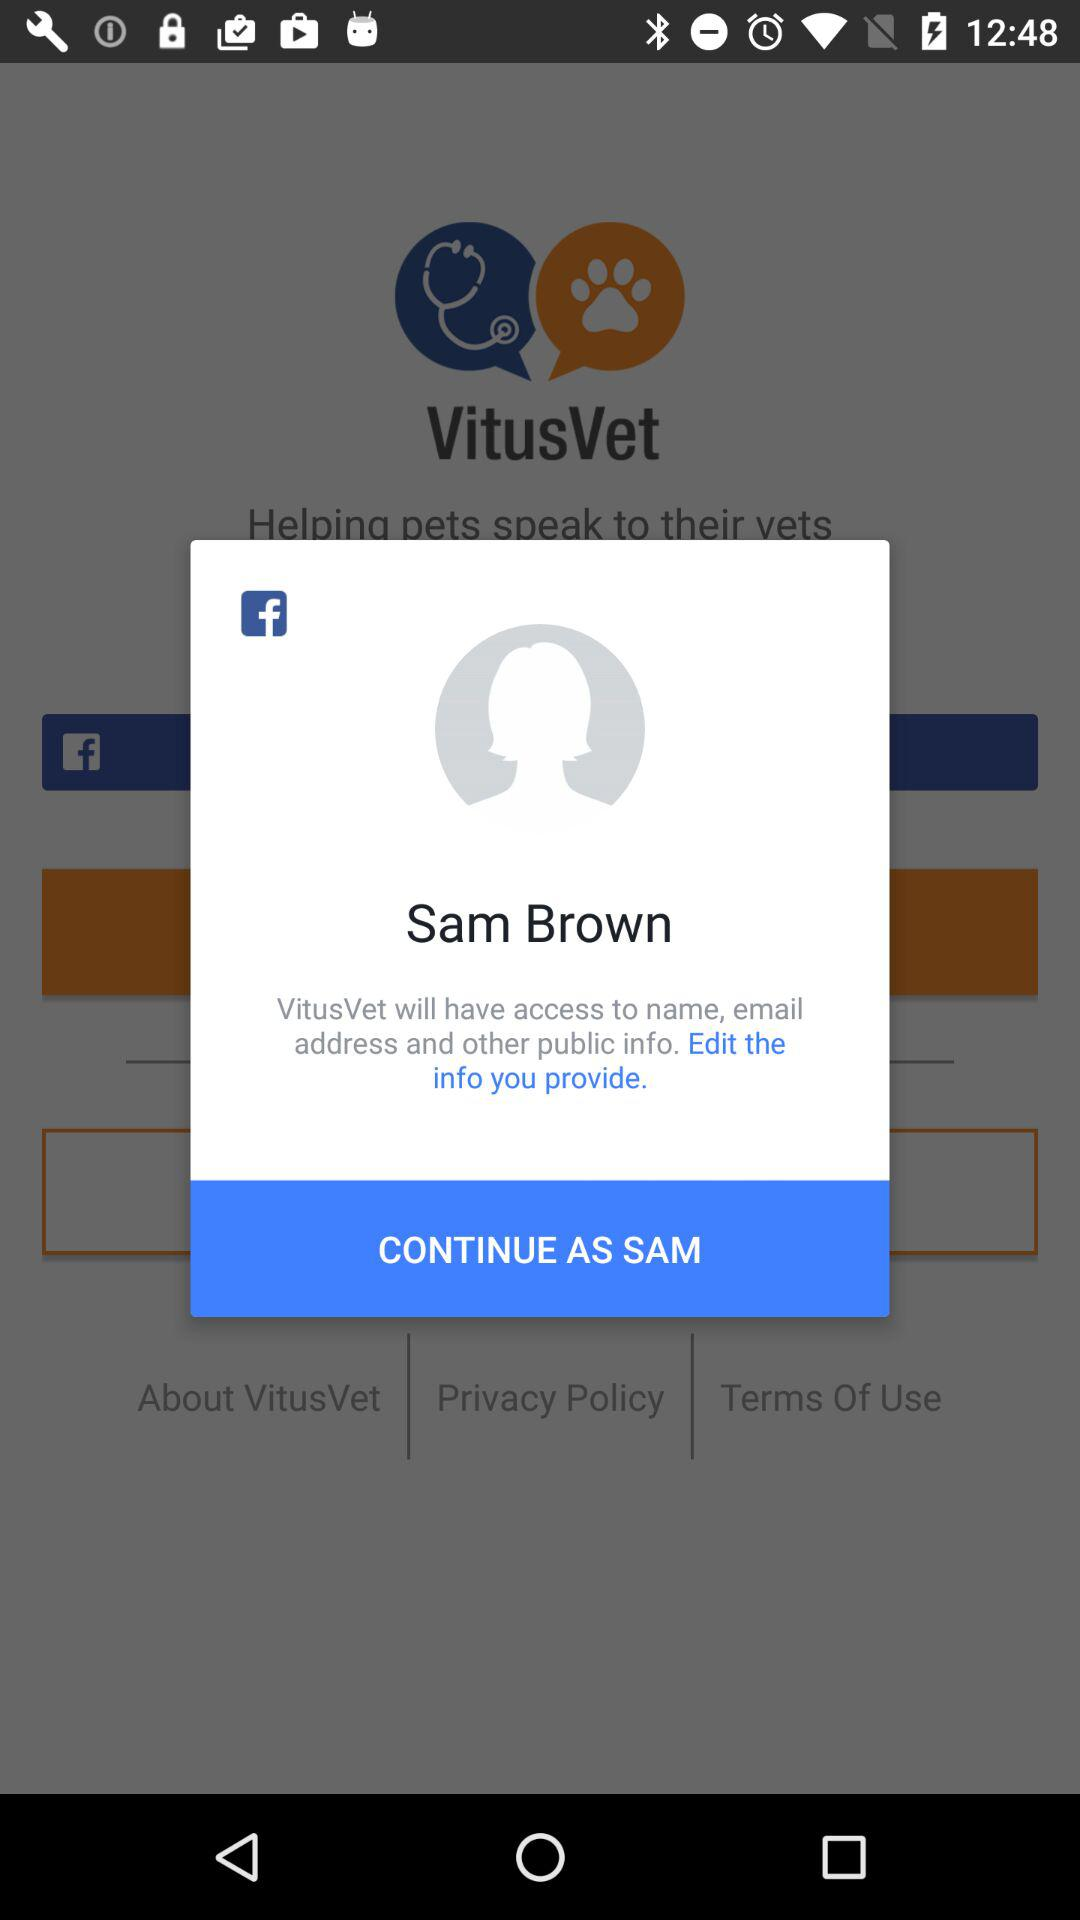What is the name of the user? The name of the user is Sam Brown. 